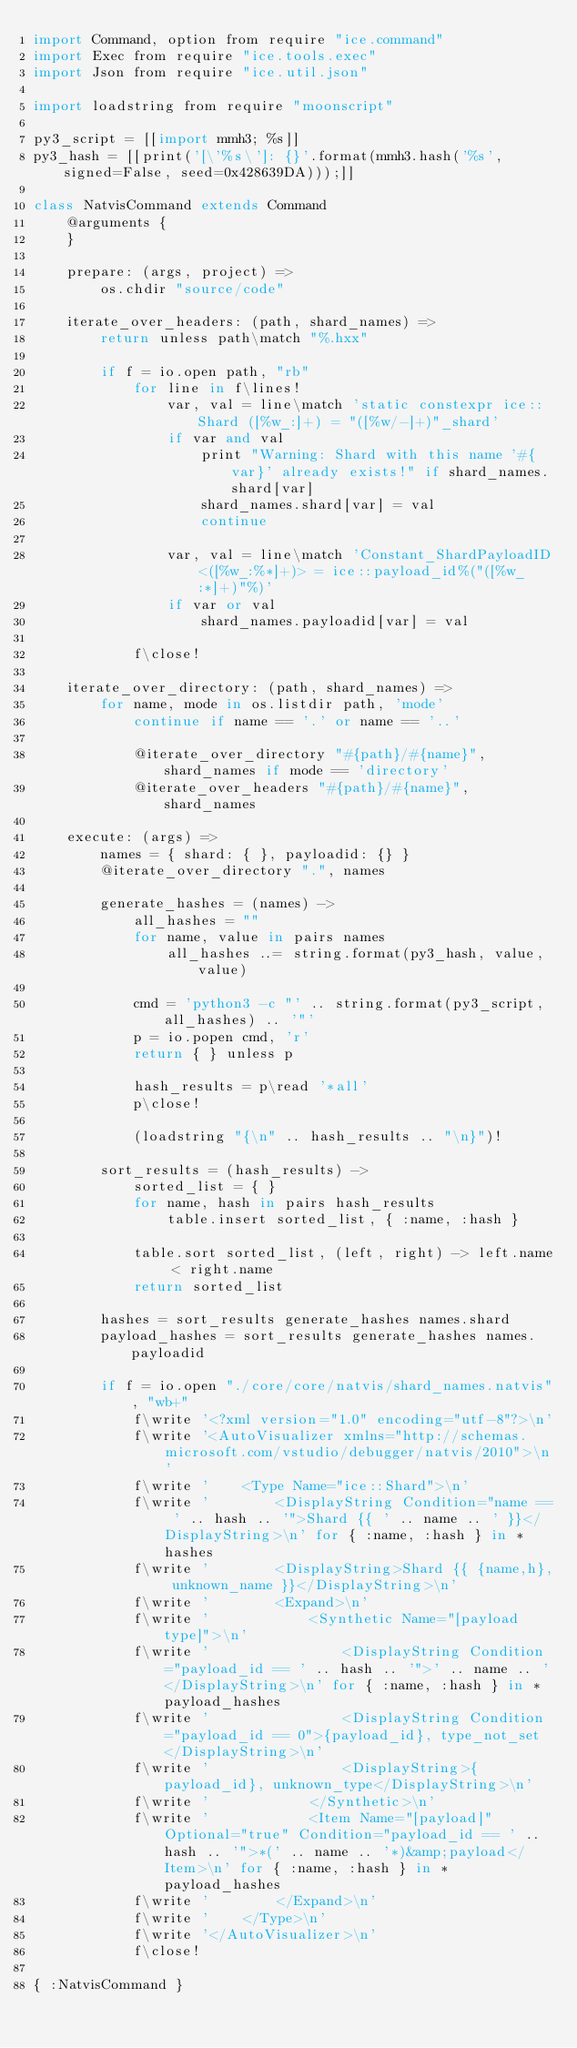<code> <loc_0><loc_0><loc_500><loc_500><_MoonScript_>import Command, option from require "ice.command"
import Exec from require "ice.tools.exec"
import Json from require "ice.util.json"

import loadstring from require "moonscript"

py3_script = [[import mmh3; %s]]
py3_hash = [[print('[\'%s\']: {}'.format(mmh3.hash('%s', signed=False, seed=0x428639DA)));]]

class NatvisCommand extends Command
    @arguments {
    }

    prepare: (args, project) =>
        os.chdir "source/code"

    iterate_over_headers: (path, shard_names) =>
        return unless path\match "%.hxx"

        if f = io.open path, "rb"
            for line in f\lines!
                var, val = line\match 'static constexpr ice::Shard ([%w_:]+) = "([%w/-]+)"_shard'
                if var and val
                    print "Warning: Shard with this name '#{var}' already exists!" if shard_names.shard[var]
                    shard_names.shard[var] = val
                    continue

                var, val = line\match 'Constant_ShardPayloadID<([%w_:%*]+)> = ice::payload_id%("([%w_:*]+)"%)'
                if var or val
                    shard_names.payloadid[var] = val

            f\close!

    iterate_over_directory: (path, shard_names) =>
        for name, mode in os.listdir path, 'mode'
            continue if name == '.' or name == '..'

            @iterate_over_directory "#{path}/#{name}", shard_names if mode == 'directory'
            @iterate_over_headers "#{path}/#{name}", shard_names

    execute: (args) =>
        names = { shard: { }, payloadid: {} }
        @iterate_over_directory ".", names

        generate_hashes = (names) ->
            all_hashes = ""
            for name, value in pairs names
                all_hashes ..= string.format(py3_hash, value, value)

            cmd = 'python3 -c "' .. string.format(py3_script, all_hashes) .. '"'
            p = io.popen cmd, 'r'
            return { } unless p

            hash_results = p\read '*all'
            p\close!

            (loadstring "{\n" .. hash_results .. "\n}")!

        sort_results = (hash_results) ->
            sorted_list = { }
            for name, hash in pairs hash_results
                table.insert sorted_list, { :name, :hash }

            table.sort sorted_list, (left, right) -> left.name < right.name
            return sorted_list

        hashes = sort_results generate_hashes names.shard
        payload_hashes = sort_results generate_hashes names.payloadid

        if f = io.open "./core/core/natvis/shard_names.natvis", "wb+"
            f\write '<?xml version="1.0" encoding="utf-8"?>\n'
            f\write '<AutoVisualizer xmlns="http://schemas.microsoft.com/vstudio/debugger/natvis/2010">\n'
            f\write '    <Type Name="ice::Shard">\n'
            f\write '        <DisplayString Condition="name == ' .. hash .. '">Shard {{ ' .. name .. ' }}</DisplayString>\n' for { :name, :hash } in *hashes
            f\write '        <DisplayString>Shard {{ {name,h}, unknown_name }}</DisplayString>\n'
            f\write '        <Expand>\n'
            f\write '            <Synthetic Name="[payload type]">\n'
            f\write '                <DisplayString Condition="payload_id == ' .. hash .. '">' .. name .. '</DisplayString>\n' for { :name, :hash } in *payload_hashes
            f\write '                <DisplayString Condition="payload_id == 0">{payload_id}, type_not_set</DisplayString>\n'
            f\write '                <DisplayString>{payload_id}, unknown_type</DisplayString>\n'
            f\write '            </Synthetic>\n'
            f\write '            <Item Name="[payload]" Optional="true" Condition="payload_id == ' .. hash .. '">*(' .. name .. '*)&amp;payload</Item>\n' for { :name, :hash } in *payload_hashes
            f\write '        </Expand>\n'
            f\write '    </Type>\n'
            f\write '</AutoVisualizer>\n'
            f\close!

{ :NatvisCommand }
</code> 